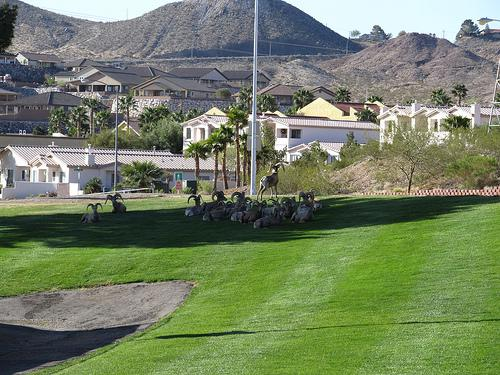Question: what is providing the shade?
Choices:
A. A building.
B. A tree.
C. A tent.
D. A car.
Answer with the letter. Answer: B Question: what color is the grass?
Choices:
A. Grey.
B. Brown.
C. Yellow.
D. Green.
Answer with the letter. Answer: D Question: why are the rams in the shade?
Choices:
A. It is hot.
B. They are tired.
C. They are sleeping.
D. It is sunny.
Answer with the letter. Answer: D Question: who took the photo?
Choices:
A. Japanese tourist.
B. Photographer.
C. Woman.
D. An onlooker.
Answer with the letter. Answer: D Question: when was the photo taken?
Choices:
A. Morning.
B. During the day.
C. Noon.
D. Dusk.
Answer with the letter. Answer: B 